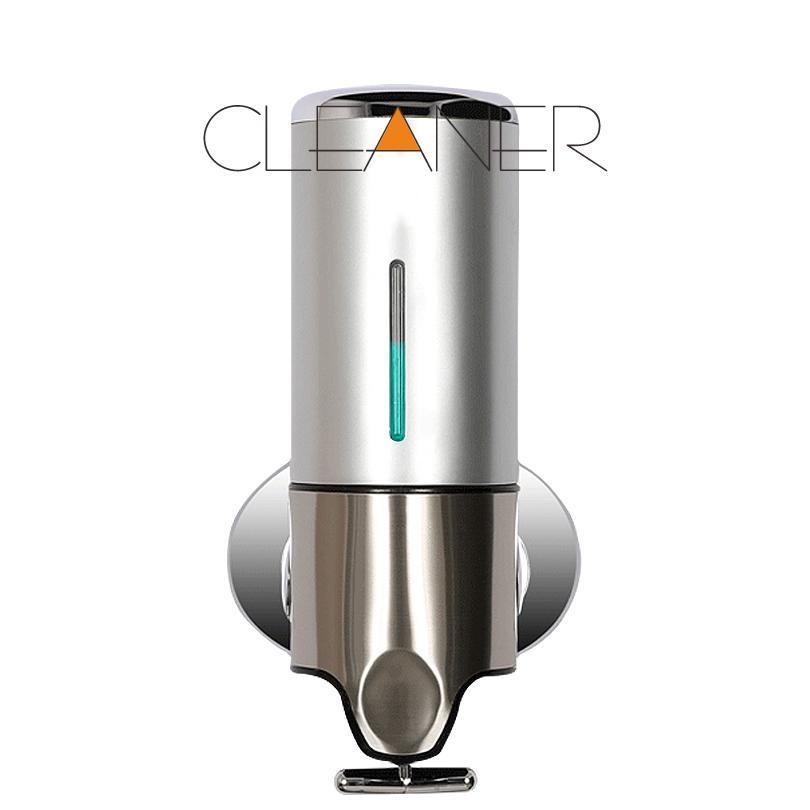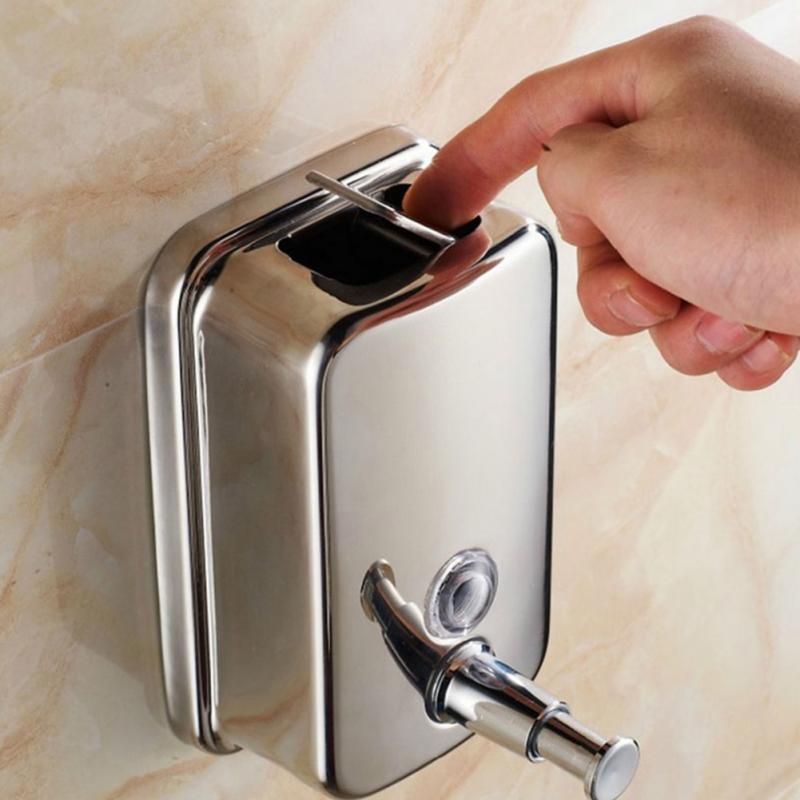The first image is the image on the left, the second image is the image on the right. For the images shown, is this caption "Both images contain three liquid bathroom product dispensers." true? Answer yes or no. No. The first image is the image on the left, the second image is the image on the right. Evaluate the accuracy of this statement regarding the images: "The image to the right features three soap dispensers.". Is it true? Answer yes or no. No. 